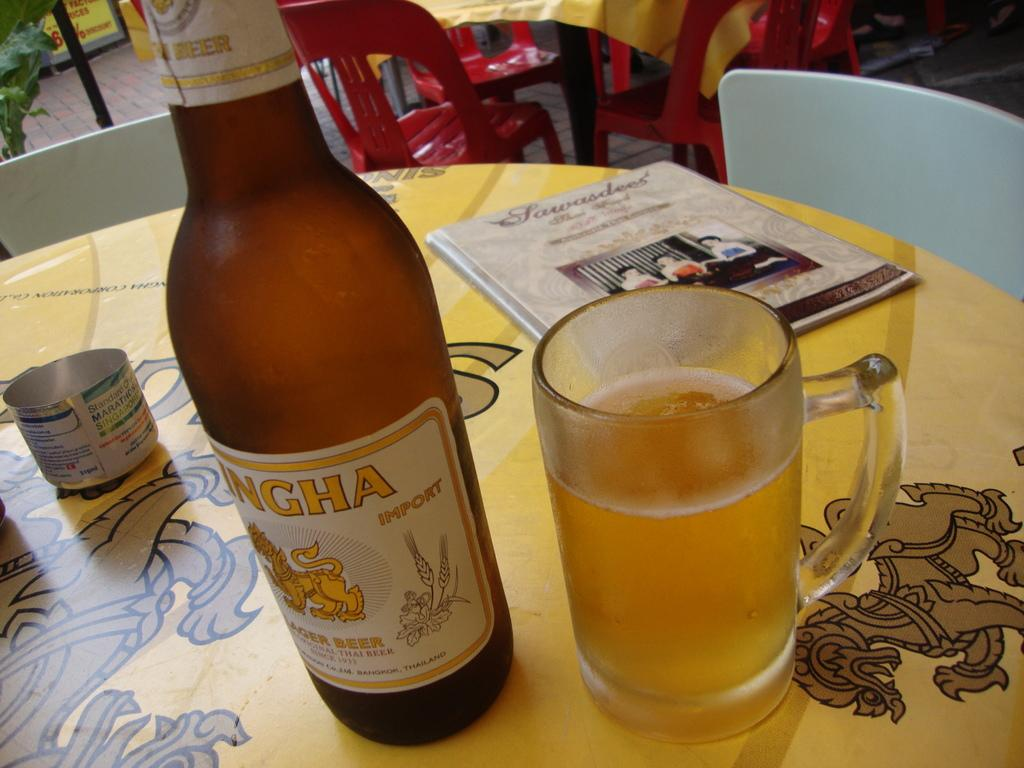<image>
Write a terse but informative summary of the picture. the letters HA are on the front of the bottle 